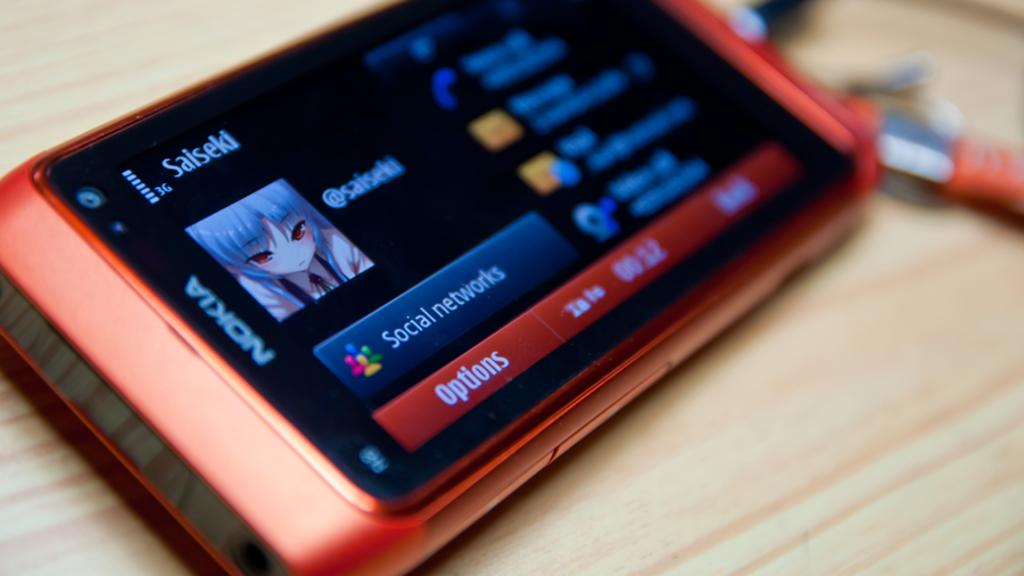<image>
Present a compact description of the photo's key features. An orange Nokia smartphone showing a screen with an anime style avatar. 